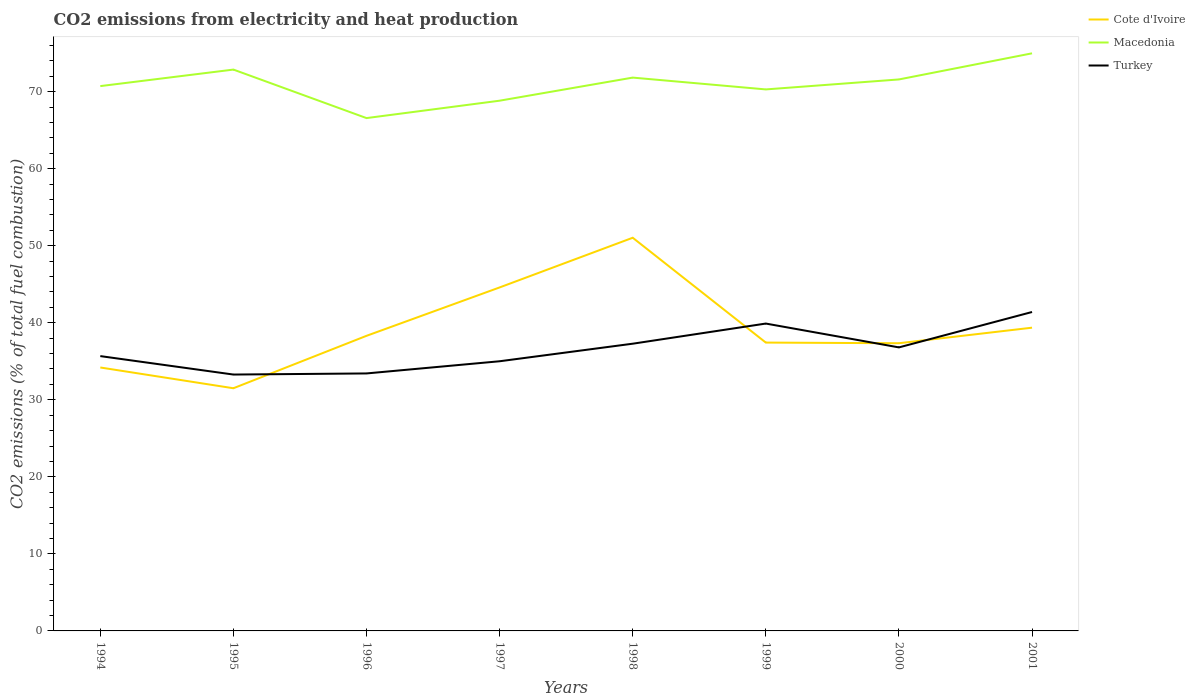How many different coloured lines are there?
Offer a terse response. 3. Does the line corresponding to Cote d'Ivoire intersect with the line corresponding to Turkey?
Give a very brief answer. Yes. Across all years, what is the maximum amount of CO2 emitted in Turkey?
Provide a short and direct response. 33.28. What is the total amount of CO2 emitted in Turkey in the graph?
Offer a terse response. -6.39. What is the difference between the highest and the second highest amount of CO2 emitted in Macedonia?
Provide a short and direct response. 8.41. How many years are there in the graph?
Your answer should be compact. 8. What is the difference between two consecutive major ticks on the Y-axis?
Ensure brevity in your answer.  10. Are the values on the major ticks of Y-axis written in scientific E-notation?
Your answer should be very brief. No. Does the graph contain any zero values?
Make the answer very short. No. Does the graph contain grids?
Provide a succinct answer. No. Where does the legend appear in the graph?
Your response must be concise. Top right. How are the legend labels stacked?
Your answer should be compact. Vertical. What is the title of the graph?
Provide a succinct answer. CO2 emissions from electricity and heat production. Does "Palau" appear as one of the legend labels in the graph?
Your response must be concise. No. What is the label or title of the Y-axis?
Keep it short and to the point. CO2 emissions (% of total fuel combustion). What is the CO2 emissions (% of total fuel combustion) of Cote d'Ivoire in 1994?
Your response must be concise. 34.19. What is the CO2 emissions (% of total fuel combustion) of Macedonia in 1994?
Ensure brevity in your answer.  70.72. What is the CO2 emissions (% of total fuel combustion) of Turkey in 1994?
Keep it short and to the point. 35.67. What is the CO2 emissions (% of total fuel combustion) of Cote d'Ivoire in 1995?
Provide a short and direct response. 31.5. What is the CO2 emissions (% of total fuel combustion) of Macedonia in 1995?
Give a very brief answer. 72.86. What is the CO2 emissions (% of total fuel combustion) of Turkey in 1995?
Offer a terse response. 33.28. What is the CO2 emissions (% of total fuel combustion) of Cote d'Ivoire in 1996?
Offer a very short reply. 38.3. What is the CO2 emissions (% of total fuel combustion) of Macedonia in 1996?
Your response must be concise. 66.56. What is the CO2 emissions (% of total fuel combustion) in Turkey in 1996?
Your answer should be compact. 33.42. What is the CO2 emissions (% of total fuel combustion) in Cote d'Ivoire in 1997?
Provide a succinct answer. 44.58. What is the CO2 emissions (% of total fuel combustion) in Macedonia in 1997?
Ensure brevity in your answer.  68.82. What is the CO2 emissions (% of total fuel combustion) in Turkey in 1997?
Your answer should be compact. 35. What is the CO2 emissions (% of total fuel combustion) of Cote d'Ivoire in 1998?
Provide a succinct answer. 51.03. What is the CO2 emissions (% of total fuel combustion) of Macedonia in 1998?
Offer a terse response. 71.82. What is the CO2 emissions (% of total fuel combustion) in Turkey in 1998?
Your answer should be compact. 37.28. What is the CO2 emissions (% of total fuel combustion) in Cote d'Ivoire in 1999?
Make the answer very short. 37.43. What is the CO2 emissions (% of total fuel combustion) in Macedonia in 1999?
Your answer should be very brief. 70.29. What is the CO2 emissions (% of total fuel combustion) of Turkey in 1999?
Offer a terse response. 39.89. What is the CO2 emissions (% of total fuel combustion) in Cote d'Ivoire in 2000?
Offer a terse response. 37.34. What is the CO2 emissions (% of total fuel combustion) in Macedonia in 2000?
Your answer should be compact. 71.58. What is the CO2 emissions (% of total fuel combustion) in Turkey in 2000?
Offer a terse response. 36.8. What is the CO2 emissions (% of total fuel combustion) of Cote d'Ivoire in 2001?
Provide a succinct answer. 39.36. What is the CO2 emissions (% of total fuel combustion) in Macedonia in 2001?
Provide a succinct answer. 74.97. What is the CO2 emissions (% of total fuel combustion) of Turkey in 2001?
Ensure brevity in your answer.  41.39. Across all years, what is the maximum CO2 emissions (% of total fuel combustion) in Cote d'Ivoire?
Your answer should be compact. 51.03. Across all years, what is the maximum CO2 emissions (% of total fuel combustion) in Macedonia?
Ensure brevity in your answer.  74.97. Across all years, what is the maximum CO2 emissions (% of total fuel combustion) of Turkey?
Ensure brevity in your answer.  41.39. Across all years, what is the minimum CO2 emissions (% of total fuel combustion) in Cote d'Ivoire?
Your answer should be very brief. 31.5. Across all years, what is the minimum CO2 emissions (% of total fuel combustion) of Macedonia?
Provide a succinct answer. 66.56. Across all years, what is the minimum CO2 emissions (% of total fuel combustion) in Turkey?
Offer a terse response. 33.28. What is the total CO2 emissions (% of total fuel combustion) of Cote d'Ivoire in the graph?
Offer a terse response. 313.74. What is the total CO2 emissions (% of total fuel combustion) in Macedonia in the graph?
Keep it short and to the point. 567.62. What is the total CO2 emissions (% of total fuel combustion) in Turkey in the graph?
Provide a succinct answer. 292.74. What is the difference between the CO2 emissions (% of total fuel combustion) in Cote d'Ivoire in 1994 and that in 1995?
Provide a short and direct response. 2.7. What is the difference between the CO2 emissions (% of total fuel combustion) of Macedonia in 1994 and that in 1995?
Give a very brief answer. -2.14. What is the difference between the CO2 emissions (% of total fuel combustion) of Turkey in 1994 and that in 1995?
Your answer should be very brief. 2.39. What is the difference between the CO2 emissions (% of total fuel combustion) of Cote d'Ivoire in 1994 and that in 1996?
Provide a short and direct response. -4.11. What is the difference between the CO2 emissions (% of total fuel combustion) of Macedonia in 1994 and that in 1996?
Your answer should be compact. 4.15. What is the difference between the CO2 emissions (% of total fuel combustion) of Turkey in 1994 and that in 1996?
Your answer should be very brief. 2.25. What is the difference between the CO2 emissions (% of total fuel combustion) of Cote d'Ivoire in 1994 and that in 1997?
Give a very brief answer. -10.39. What is the difference between the CO2 emissions (% of total fuel combustion) in Macedonia in 1994 and that in 1997?
Offer a terse response. 1.89. What is the difference between the CO2 emissions (% of total fuel combustion) of Turkey in 1994 and that in 1997?
Make the answer very short. 0.67. What is the difference between the CO2 emissions (% of total fuel combustion) of Cote d'Ivoire in 1994 and that in 1998?
Keep it short and to the point. -16.84. What is the difference between the CO2 emissions (% of total fuel combustion) of Macedonia in 1994 and that in 1998?
Your response must be concise. -1.1. What is the difference between the CO2 emissions (% of total fuel combustion) of Turkey in 1994 and that in 1998?
Your answer should be compact. -1.61. What is the difference between the CO2 emissions (% of total fuel combustion) in Cote d'Ivoire in 1994 and that in 1999?
Offer a terse response. -3.23. What is the difference between the CO2 emissions (% of total fuel combustion) of Macedonia in 1994 and that in 1999?
Your response must be concise. 0.43. What is the difference between the CO2 emissions (% of total fuel combustion) of Turkey in 1994 and that in 1999?
Make the answer very short. -4.22. What is the difference between the CO2 emissions (% of total fuel combustion) of Cote d'Ivoire in 1994 and that in 2000?
Make the answer very short. -3.15. What is the difference between the CO2 emissions (% of total fuel combustion) of Macedonia in 1994 and that in 2000?
Provide a short and direct response. -0.86. What is the difference between the CO2 emissions (% of total fuel combustion) in Turkey in 1994 and that in 2000?
Your answer should be very brief. -1.13. What is the difference between the CO2 emissions (% of total fuel combustion) in Cote d'Ivoire in 1994 and that in 2001?
Offer a very short reply. -5.17. What is the difference between the CO2 emissions (% of total fuel combustion) of Macedonia in 1994 and that in 2001?
Offer a very short reply. -4.25. What is the difference between the CO2 emissions (% of total fuel combustion) of Turkey in 1994 and that in 2001?
Offer a terse response. -5.72. What is the difference between the CO2 emissions (% of total fuel combustion) of Cote d'Ivoire in 1995 and that in 1996?
Your answer should be very brief. -6.8. What is the difference between the CO2 emissions (% of total fuel combustion) in Macedonia in 1995 and that in 1996?
Provide a short and direct response. 6.3. What is the difference between the CO2 emissions (% of total fuel combustion) in Turkey in 1995 and that in 1996?
Your answer should be compact. -0.14. What is the difference between the CO2 emissions (% of total fuel combustion) of Cote d'Ivoire in 1995 and that in 1997?
Keep it short and to the point. -13.08. What is the difference between the CO2 emissions (% of total fuel combustion) in Macedonia in 1995 and that in 1997?
Ensure brevity in your answer.  4.04. What is the difference between the CO2 emissions (% of total fuel combustion) in Turkey in 1995 and that in 1997?
Your answer should be compact. -1.72. What is the difference between the CO2 emissions (% of total fuel combustion) in Cote d'Ivoire in 1995 and that in 1998?
Provide a short and direct response. -19.53. What is the difference between the CO2 emissions (% of total fuel combustion) in Macedonia in 1995 and that in 1998?
Offer a very short reply. 1.04. What is the difference between the CO2 emissions (% of total fuel combustion) of Turkey in 1995 and that in 1998?
Your response must be concise. -4. What is the difference between the CO2 emissions (% of total fuel combustion) in Cote d'Ivoire in 1995 and that in 1999?
Ensure brevity in your answer.  -5.93. What is the difference between the CO2 emissions (% of total fuel combustion) in Macedonia in 1995 and that in 1999?
Make the answer very short. 2.57. What is the difference between the CO2 emissions (% of total fuel combustion) of Turkey in 1995 and that in 1999?
Make the answer very short. -6.62. What is the difference between the CO2 emissions (% of total fuel combustion) in Cote d'Ivoire in 1995 and that in 2000?
Your answer should be very brief. -5.84. What is the difference between the CO2 emissions (% of total fuel combustion) of Macedonia in 1995 and that in 2000?
Give a very brief answer. 1.28. What is the difference between the CO2 emissions (% of total fuel combustion) in Turkey in 1995 and that in 2000?
Keep it short and to the point. -3.53. What is the difference between the CO2 emissions (% of total fuel combustion) of Cote d'Ivoire in 1995 and that in 2001?
Offer a terse response. -7.86. What is the difference between the CO2 emissions (% of total fuel combustion) in Macedonia in 1995 and that in 2001?
Provide a succinct answer. -2.11. What is the difference between the CO2 emissions (% of total fuel combustion) in Turkey in 1995 and that in 2001?
Provide a short and direct response. -8.12. What is the difference between the CO2 emissions (% of total fuel combustion) of Cote d'Ivoire in 1996 and that in 1997?
Provide a short and direct response. -6.28. What is the difference between the CO2 emissions (% of total fuel combustion) of Macedonia in 1996 and that in 1997?
Your response must be concise. -2.26. What is the difference between the CO2 emissions (% of total fuel combustion) of Turkey in 1996 and that in 1997?
Your answer should be very brief. -1.58. What is the difference between the CO2 emissions (% of total fuel combustion) of Cote d'Ivoire in 1996 and that in 1998?
Offer a very short reply. -12.73. What is the difference between the CO2 emissions (% of total fuel combustion) in Macedonia in 1996 and that in 1998?
Offer a very short reply. -5.26. What is the difference between the CO2 emissions (% of total fuel combustion) of Turkey in 1996 and that in 1998?
Provide a succinct answer. -3.86. What is the difference between the CO2 emissions (% of total fuel combustion) in Cote d'Ivoire in 1996 and that in 1999?
Keep it short and to the point. 0.88. What is the difference between the CO2 emissions (% of total fuel combustion) in Macedonia in 1996 and that in 1999?
Offer a terse response. -3.72. What is the difference between the CO2 emissions (% of total fuel combustion) in Turkey in 1996 and that in 1999?
Your answer should be very brief. -6.47. What is the difference between the CO2 emissions (% of total fuel combustion) of Cote d'Ivoire in 1996 and that in 2000?
Ensure brevity in your answer.  0.96. What is the difference between the CO2 emissions (% of total fuel combustion) of Macedonia in 1996 and that in 2000?
Provide a succinct answer. -5.02. What is the difference between the CO2 emissions (% of total fuel combustion) of Turkey in 1996 and that in 2000?
Your answer should be compact. -3.38. What is the difference between the CO2 emissions (% of total fuel combustion) in Cote d'Ivoire in 1996 and that in 2001?
Give a very brief answer. -1.06. What is the difference between the CO2 emissions (% of total fuel combustion) of Macedonia in 1996 and that in 2001?
Your response must be concise. -8.41. What is the difference between the CO2 emissions (% of total fuel combustion) in Turkey in 1996 and that in 2001?
Provide a short and direct response. -7.97. What is the difference between the CO2 emissions (% of total fuel combustion) in Cote d'Ivoire in 1997 and that in 1998?
Your answer should be very brief. -6.45. What is the difference between the CO2 emissions (% of total fuel combustion) of Macedonia in 1997 and that in 1998?
Your answer should be very brief. -3. What is the difference between the CO2 emissions (% of total fuel combustion) of Turkey in 1997 and that in 1998?
Keep it short and to the point. -2.28. What is the difference between the CO2 emissions (% of total fuel combustion) of Cote d'Ivoire in 1997 and that in 1999?
Offer a terse response. 7.16. What is the difference between the CO2 emissions (% of total fuel combustion) in Macedonia in 1997 and that in 1999?
Keep it short and to the point. -1.46. What is the difference between the CO2 emissions (% of total fuel combustion) of Turkey in 1997 and that in 1999?
Your response must be concise. -4.89. What is the difference between the CO2 emissions (% of total fuel combustion) in Cote d'Ivoire in 1997 and that in 2000?
Keep it short and to the point. 7.24. What is the difference between the CO2 emissions (% of total fuel combustion) of Macedonia in 1997 and that in 2000?
Provide a short and direct response. -2.76. What is the difference between the CO2 emissions (% of total fuel combustion) of Turkey in 1997 and that in 2000?
Your response must be concise. -1.8. What is the difference between the CO2 emissions (% of total fuel combustion) in Cote d'Ivoire in 1997 and that in 2001?
Your answer should be very brief. 5.22. What is the difference between the CO2 emissions (% of total fuel combustion) in Macedonia in 1997 and that in 2001?
Ensure brevity in your answer.  -6.15. What is the difference between the CO2 emissions (% of total fuel combustion) in Turkey in 1997 and that in 2001?
Provide a short and direct response. -6.39. What is the difference between the CO2 emissions (% of total fuel combustion) in Cote d'Ivoire in 1998 and that in 1999?
Make the answer very short. 13.61. What is the difference between the CO2 emissions (% of total fuel combustion) in Macedonia in 1998 and that in 1999?
Ensure brevity in your answer.  1.53. What is the difference between the CO2 emissions (% of total fuel combustion) in Turkey in 1998 and that in 1999?
Provide a succinct answer. -2.61. What is the difference between the CO2 emissions (% of total fuel combustion) in Cote d'Ivoire in 1998 and that in 2000?
Offer a very short reply. 13.69. What is the difference between the CO2 emissions (% of total fuel combustion) in Macedonia in 1998 and that in 2000?
Your response must be concise. 0.24. What is the difference between the CO2 emissions (% of total fuel combustion) in Turkey in 1998 and that in 2000?
Keep it short and to the point. 0.48. What is the difference between the CO2 emissions (% of total fuel combustion) of Cote d'Ivoire in 1998 and that in 2001?
Offer a terse response. 11.67. What is the difference between the CO2 emissions (% of total fuel combustion) of Macedonia in 1998 and that in 2001?
Offer a terse response. -3.15. What is the difference between the CO2 emissions (% of total fuel combustion) in Turkey in 1998 and that in 2001?
Your answer should be compact. -4.11. What is the difference between the CO2 emissions (% of total fuel combustion) of Cote d'Ivoire in 1999 and that in 2000?
Give a very brief answer. 0.08. What is the difference between the CO2 emissions (% of total fuel combustion) of Macedonia in 1999 and that in 2000?
Your response must be concise. -1.3. What is the difference between the CO2 emissions (% of total fuel combustion) in Turkey in 1999 and that in 2000?
Your answer should be compact. 3.09. What is the difference between the CO2 emissions (% of total fuel combustion) of Cote d'Ivoire in 1999 and that in 2001?
Provide a succinct answer. -1.93. What is the difference between the CO2 emissions (% of total fuel combustion) of Macedonia in 1999 and that in 2001?
Offer a very short reply. -4.68. What is the difference between the CO2 emissions (% of total fuel combustion) in Cote d'Ivoire in 2000 and that in 2001?
Your response must be concise. -2.02. What is the difference between the CO2 emissions (% of total fuel combustion) in Macedonia in 2000 and that in 2001?
Make the answer very short. -3.39. What is the difference between the CO2 emissions (% of total fuel combustion) of Turkey in 2000 and that in 2001?
Keep it short and to the point. -4.59. What is the difference between the CO2 emissions (% of total fuel combustion) in Cote d'Ivoire in 1994 and the CO2 emissions (% of total fuel combustion) in Macedonia in 1995?
Keep it short and to the point. -38.67. What is the difference between the CO2 emissions (% of total fuel combustion) in Cote d'Ivoire in 1994 and the CO2 emissions (% of total fuel combustion) in Turkey in 1995?
Provide a short and direct response. 0.92. What is the difference between the CO2 emissions (% of total fuel combustion) in Macedonia in 1994 and the CO2 emissions (% of total fuel combustion) in Turkey in 1995?
Your answer should be compact. 37.44. What is the difference between the CO2 emissions (% of total fuel combustion) of Cote d'Ivoire in 1994 and the CO2 emissions (% of total fuel combustion) of Macedonia in 1996?
Keep it short and to the point. -32.37. What is the difference between the CO2 emissions (% of total fuel combustion) in Cote d'Ivoire in 1994 and the CO2 emissions (% of total fuel combustion) in Turkey in 1996?
Your answer should be very brief. 0.77. What is the difference between the CO2 emissions (% of total fuel combustion) in Macedonia in 1994 and the CO2 emissions (% of total fuel combustion) in Turkey in 1996?
Offer a terse response. 37.3. What is the difference between the CO2 emissions (% of total fuel combustion) in Cote d'Ivoire in 1994 and the CO2 emissions (% of total fuel combustion) in Macedonia in 1997?
Your response must be concise. -34.63. What is the difference between the CO2 emissions (% of total fuel combustion) of Cote d'Ivoire in 1994 and the CO2 emissions (% of total fuel combustion) of Turkey in 1997?
Offer a terse response. -0.81. What is the difference between the CO2 emissions (% of total fuel combustion) in Macedonia in 1994 and the CO2 emissions (% of total fuel combustion) in Turkey in 1997?
Keep it short and to the point. 35.72. What is the difference between the CO2 emissions (% of total fuel combustion) of Cote d'Ivoire in 1994 and the CO2 emissions (% of total fuel combustion) of Macedonia in 1998?
Provide a succinct answer. -37.63. What is the difference between the CO2 emissions (% of total fuel combustion) of Cote d'Ivoire in 1994 and the CO2 emissions (% of total fuel combustion) of Turkey in 1998?
Offer a terse response. -3.09. What is the difference between the CO2 emissions (% of total fuel combustion) in Macedonia in 1994 and the CO2 emissions (% of total fuel combustion) in Turkey in 1998?
Provide a short and direct response. 33.44. What is the difference between the CO2 emissions (% of total fuel combustion) in Cote d'Ivoire in 1994 and the CO2 emissions (% of total fuel combustion) in Macedonia in 1999?
Make the answer very short. -36.09. What is the difference between the CO2 emissions (% of total fuel combustion) in Cote d'Ivoire in 1994 and the CO2 emissions (% of total fuel combustion) in Turkey in 1999?
Your answer should be very brief. -5.7. What is the difference between the CO2 emissions (% of total fuel combustion) of Macedonia in 1994 and the CO2 emissions (% of total fuel combustion) of Turkey in 1999?
Offer a very short reply. 30.82. What is the difference between the CO2 emissions (% of total fuel combustion) in Cote d'Ivoire in 1994 and the CO2 emissions (% of total fuel combustion) in Macedonia in 2000?
Offer a very short reply. -37.39. What is the difference between the CO2 emissions (% of total fuel combustion) in Cote d'Ivoire in 1994 and the CO2 emissions (% of total fuel combustion) in Turkey in 2000?
Make the answer very short. -2.61. What is the difference between the CO2 emissions (% of total fuel combustion) in Macedonia in 1994 and the CO2 emissions (% of total fuel combustion) in Turkey in 2000?
Provide a succinct answer. 33.91. What is the difference between the CO2 emissions (% of total fuel combustion) in Cote d'Ivoire in 1994 and the CO2 emissions (% of total fuel combustion) in Macedonia in 2001?
Provide a short and direct response. -40.78. What is the difference between the CO2 emissions (% of total fuel combustion) in Cote d'Ivoire in 1994 and the CO2 emissions (% of total fuel combustion) in Turkey in 2001?
Make the answer very short. -7.2. What is the difference between the CO2 emissions (% of total fuel combustion) in Macedonia in 1994 and the CO2 emissions (% of total fuel combustion) in Turkey in 2001?
Ensure brevity in your answer.  29.32. What is the difference between the CO2 emissions (% of total fuel combustion) in Cote d'Ivoire in 1995 and the CO2 emissions (% of total fuel combustion) in Macedonia in 1996?
Make the answer very short. -35.07. What is the difference between the CO2 emissions (% of total fuel combustion) in Cote d'Ivoire in 1995 and the CO2 emissions (% of total fuel combustion) in Turkey in 1996?
Ensure brevity in your answer.  -1.92. What is the difference between the CO2 emissions (% of total fuel combustion) in Macedonia in 1995 and the CO2 emissions (% of total fuel combustion) in Turkey in 1996?
Offer a very short reply. 39.44. What is the difference between the CO2 emissions (% of total fuel combustion) in Cote d'Ivoire in 1995 and the CO2 emissions (% of total fuel combustion) in Macedonia in 1997?
Keep it short and to the point. -37.32. What is the difference between the CO2 emissions (% of total fuel combustion) of Cote d'Ivoire in 1995 and the CO2 emissions (% of total fuel combustion) of Turkey in 1997?
Offer a terse response. -3.5. What is the difference between the CO2 emissions (% of total fuel combustion) in Macedonia in 1995 and the CO2 emissions (% of total fuel combustion) in Turkey in 1997?
Ensure brevity in your answer.  37.86. What is the difference between the CO2 emissions (% of total fuel combustion) of Cote d'Ivoire in 1995 and the CO2 emissions (% of total fuel combustion) of Macedonia in 1998?
Make the answer very short. -40.32. What is the difference between the CO2 emissions (% of total fuel combustion) in Cote d'Ivoire in 1995 and the CO2 emissions (% of total fuel combustion) in Turkey in 1998?
Keep it short and to the point. -5.78. What is the difference between the CO2 emissions (% of total fuel combustion) of Macedonia in 1995 and the CO2 emissions (% of total fuel combustion) of Turkey in 1998?
Your answer should be compact. 35.58. What is the difference between the CO2 emissions (% of total fuel combustion) of Cote d'Ivoire in 1995 and the CO2 emissions (% of total fuel combustion) of Macedonia in 1999?
Your answer should be compact. -38.79. What is the difference between the CO2 emissions (% of total fuel combustion) in Cote d'Ivoire in 1995 and the CO2 emissions (% of total fuel combustion) in Turkey in 1999?
Your answer should be compact. -8.4. What is the difference between the CO2 emissions (% of total fuel combustion) of Macedonia in 1995 and the CO2 emissions (% of total fuel combustion) of Turkey in 1999?
Provide a succinct answer. 32.97. What is the difference between the CO2 emissions (% of total fuel combustion) in Cote d'Ivoire in 1995 and the CO2 emissions (% of total fuel combustion) in Macedonia in 2000?
Your answer should be compact. -40.08. What is the difference between the CO2 emissions (% of total fuel combustion) in Cote d'Ivoire in 1995 and the CO2 emissions (% of total fuel combustion) in Turkey in 2000?
Make the answer very short. -5.3. What is the difference between the CO2 emissions (% of total fuel combustion) in Macedonia in 1995 and the CO2 emissions (% of total fuel combustion) in Turkey in 2000?
Your response must be concise. 36.06. What is the difference between the CO2 emissions (% of total fuel combustion) of Cote d'Ivoire in 1995 and the CO2 emissions (% of total fuel combustion) of Macedonia in 2001?
Provide a short and direct response. -43.47. What is the difference between the CO2 emissions (% of total fuel combustion) of Cote d'Ivoire in 1995 and the CO2 emissions (% of total fuel combustion) of Turkey in 2001?
Ensure brevity in your answer.  -9.9. What is the difference between the CO2 emissions (% of total fuel combustion) of Macedonia in 1995 and the CO2 emissions (% of total fuel combustion) of Turkey in 2001?
Give a very brief answer. 31.47. What is the difference between the CO2 emissions (% of total fuel combustion) of Cote d'Ivoire in 1996 and the CO2 emissions (% of total fuel combustion) of Macedonia in 1997?
Your answer should be compact. -30.52. What is the difference between the CO2 emissions (% of total fuel combustion) of Cote d'Ivoire in 1996 and the CO2 emissions (% of total fuel combustion) of Turkey in 1997?
Make the answer very short. 3.3. What is the difference between the CO2 emissions (% of total fuel combustion) in Macedonia in 1996 and the CO2 emissions (% of total fuel combustion) in Turkey in 1997?
Your response must be concise. 31.56. What is the difference between the CO2 emissions (% of total fuel combustion) of Cote d'Ivoire in 1996 and the CO2 emissions (% of total fuel combustion) of Macedonia in 1998?
Your answer should be compact. -33.52. What is the difference between the CO2 emissions (% of total fuel combustion) in Cote d'Ivoire in 1996 and the CO2 emissions (% of total fuel combustion) in Turkey in 1998?
Ensure brevity in your answer.  1.02. What is the difference between the CO2 emissions (% of total fuel combustion) of Macedonia in 1996 and the CO2 emissions (% of total fuel combustion) of Turkey in 1998?
Make the answer very short. 29.28. What is the difference between the CO2 emissions (% of total fuel combustion) of Cote d'Ivoire in 1996 and the CO2 emissions (% of total fuel combustion) of Macedonia in 1999?
Offer a very short reply. -31.98. What is the difference between the CO2 emissions (% of total fuel combustion) in Cote d'Ivoire in 1996 and the CO2 emissions (% of total fuel combustion) in Turkey in 1999?
Ensure brevity in your answer.  -1.59. What is the difference between the CO2 emissions (% of total fuel combustion) of Macedonia in 1996 and the CO2 emissions (% of total fuel combustion) of Turkey in 1999?
Your answer should be very brief. 26.67. What is the difference between the CO2 emissions (% of total fuel combustion) of Cote d'Ivoire in 1996 and the CO2 emissions (% of total fuel combustion) of Macedonia in 2000?
Make the answer very short. -33.28. What is the difference between the CO2 emissions (% of total fuel combustion) in Cote d'Ivoire in 1996 and the CO2 emissions (% of total fuel combustion) in Turkey in 2000?
Keep it short and to the point. 1.5. What is the difference between the CO2 emissions (% of total fuel combustion) of Macedonia in 1996 and the CO2 emissions (% of total fuel combustion) of Turkey in 2000?
Provide a short and direct response. 29.76. What is the difference between the CO2 emissions (% of total fuel combustion) in Cote d'Ivoire in 1996 and the CO2 emissions (% of total fuel combustion) in Macedonia in 2001?
Your answer should be very brief. -36.67. What is the difference between the CO2 emissions (% of total fuel combustion) of Cote d'Ivoire in 1996 and the CO2 emissions (% of total fuel combustion) of Turkey in 2001?
Provide a succinct answer. -3.09. What is the difference between the CO2 emissions (% of total fuel combustion) of Macedonia in 1996 and the CO2 emissions (% of total fuel combustion) of Turkey in 2001?
Provide a short and direct response. 25.17. What is the difference between the CO2 emissions (% of total fuel combustion) in Cote d'Ivoire in 1997 and the CO2 emissions (% of total fuel combustion) in Macedonia in 1998?
Ensure brevity in your answer.  -27.24. What is the difference between the CO2 emissions (% of total fuel combustion) in Cote d'Ivoire in 1997 and the CO2 emissions (% of total fuel combustion) in Turkey in 1998?
Make the answer very short. 7.3. What is the difference between the CO2 emissions (% of total fuel combustion) of Macedonia in 1997 and the CO2 emissions (% of total fuel combustion) of Turkey in 1998?
Give a very brief answer. 31.54. What is the difference between the CO2 emissions (% of total fuel combustion) in Cote d'Ivoire in 1997 and the CO2 emissions (% of total fuel combustion) in Macedonia in 1999?
Your answer should be compact. -25.7. What is the difference between the CO2 emissions (% of total fuel combustion) of Cote d'Ivoire in 1997 and the CO2 emissions (% of total fuel combustion) of Turkey in 1999?
Your answer should be very brief. 4.69. What is the difference between the CO2 emissions (% of total fuel combustion) in Macedonia in 1997 and the CO2 emissions (% of total fuel combustion) in Turkey in 1999?
Your response must be concise. 28.93. What is the difference between the CO2 emissions (% of total fuel combustion) in Cote d'Ivoire in 1997 and the CO2 emissions (% of total fuel combustion) in Macedonia in 2000?
Provide a succinct answer. -27. What is the difference between the CO2 emissions (% of total fuel combustion) in Cote d'Ivoire in 1997 and the CO2 emissions (% of total fuel combustion) in Turkey in 2000?
Your answer should be compact. 7.78. What is the difference between the CO2 emissions (% of total fuel combustion) in Macedonia in 1997 and the CO2 emissions (% of total fuel combustion) in Turkey in 2000?
Give a very brief answer. 32.02. What is the difference between the CO2 emissions (% of total fuel combustion) in Cote d'Ivoire in 1997 and the CO2 emissions (% of total fuel combustion) in Macedonia in 2001?
Keep it short and to the point. -30.39. What is the difference between the CO2 emissions (% of total fuel combustion) of Cote d'Ivoire in 1997 and the CO2 emissions (% of total fuel combustion) of Turkey in 2001?
Offer a very short reply. 3.19. What is the difference between the CO2 emissions (% of total fuel combustion) of Macedonia in 1997 and the CO2 emissions (% of total fuel combustion) of Turkey in 2001?
Your answer should be compact. 27.43. What is the difference between the CO2 emissions (% of total fuel combustion) of Cote d'Ivoire in 1998 and the CO2 emissions (% of total fuel combustion) of Macedonia in 1999?
Make the answer very short. -19.25. What is the difference between the CO2 emissions (% of total fuel combustion) in Cote d'Ivoire in 1998 and the CO2 emissions (% of total fuel combustion) in Turkey in 1999?
Offer a terse response. 11.14. What is the difference between the CO2 emissions (% of total fuel combustion) of Macedonia in 1998 and the CO2 emissions (% of total fuel combustion) of Turkey in 1999?
Provide a short and direct response. 31.92. What is the difference between the CO2 emissions (% of total fuel combustion) of Cote d'Ivoire in 1998 and the CO2 emissions (% of total fuel combustion) of Macedonia in 2000?
Ensure brevity in your answer.  -20.55. What is the difference between the CO2 emissions (% of total fuel combustion) in Cote d'Ivoire in 1998 and the CO2 emissions (% of total fuel combustion) in Turkey in 2000?
Provide a short and direct response. 14.23. What is the difference between the CO2 emissions (% of total fuel combustion) in Macedonia in 1998 and the CO2 emissions (% of total fuel combustion) in Turkey in 2000?
Ensure brevity in your answer.  35.02. What is the difference between the CO2 emissions (% of total fuel combustion) of Cote d'Ivoire in 1998 and the CO2 emissions (% of total fuel combustion) of Macedonia in 2001?
Your answer should be compact. -23.94. What is the difference between the CO2 emissions (% of total fuel combustion) of Cote d'Ivoire in 1998 and the CO2 emissions (% of total fuel combustion) of Turkey in 2001?
Provide a short and direct response. 9.64. What is the difference between the CO2 emissions (% of total fuel combustion) of Macedonia in 1998 and the CO2 emissions (% of total fuel combustion) of Turkey in 2001?
Your answer should be compact. 30.42. What is the difference between the CO2 emissions (% of total fuel combustion) in Cote d'Ivoire in 1999 and the CO2 emissions (% of total fuel combustion) in Macedonia in 2000?
Your response must be concise. -34.16. What is the difference between the CO2 emissions (% of total fuel combustion) of Cote d'Ivoire in 1999 and the CO2 emissions (% of total fuel combustion) of Turkey in 2000?
Your answer should be very brief. 0.62. What is the difference between the CO2 emissions (% of total fuel combustion) of Macedonia in 1999 and the CO2 emissions (% of total fuel combustion) of Turkey in 2000?
Give a very brief answer. 33.48. What is the difference between the CO2 emissions (% of total fuel combustion) in Cote d'Ivoire in 1999 and the CO2 emissions (% of total fuel combustion) in Macedonia in 2001?
Offer a very short reply. -37.55. What is the difference between the CO2 emissions (% of total fuel combustion) of Cote d'Ivoire in 1999 and the CO2 emissions (% of total fuel combustion) of Turkey in 2001?
Your answer should be very brief. -3.97. What is the difference between the CO2 emissions (% of total fuel combustion) of Macedonia in 1999 and the CO2 emissions (% of total fuel combustion) of Turkey in 2001?
Provide a short and direct response. 28.89. What is the difference between the CO2 emissions (% of total fuel combustion) of Cote d'Ivoire in 2000 and the CO2 emissions (% of total fuel combustion) of Macedonia in 2001?
Ensure brevity in your answer.  -37.63. What is the difference between the CO2 emissions (% of total fuel combustion) in Cote d'Ivoire in 2000 and the CO2 emissions (% of total fuel combustion) in Turkey in 2001?
Keep it short and to the point. -4.05. What is the difference between the CO2 emissions (% of total fuel combustion) of Macedonia in 2000 and the CO2 emissions (% of total fuel combustion) of Turkey in 2001?
Your answer should be compact. 30.19. What is the average CO2 emissions (% of total fuel combustion) in Cote d'Ivoire per year?
Make the answer very short. 39.22. What is the average CO2 emissions (% of total fuel combustion) in Macedonia per year?
Your answer should be very brief. 70.95. What is the average CO2 emissions (% of total fuel combustion) in Turkey per year?
Make the answer very short. 36.59. In the year 1994, what is the difference between the CO2 emissions (% of total fuel combustion) of Cote d'Ivoire and CO2 emissions (% of total fuel combustion) of Macedonia?
Keep it short and to the point. -36.52. In the year 1994, what is the difference between the CO2 emissions (% of total fuel combustion) in Cote d'Ivoire and CO2 emissions (% of total fuel combustion) in Turkey?
Your answer should be very brief. -1.48. In the year 1994, what is the difference between the CO2 emissions (% of total fuel combustion) in Macedonia and CO2 emissions (% of total fuel combustion) in Turkey?
Your answer should be compact. 35.05. In the year 1995, what is the difference between the CO2 emissions (% of total fuel combustion) in Cote d'Ivoire and CO2 emissions (% of total fuel combustion) in Macedonia?
Your response must be concise. -41.36. In the year 1995, what is the difference between the CO2 emissions (% of total fuel combustion) of Cote d'Ivoire and CO2 emissions (% of total fuel combustion) of Turkey?
Offer a terse response. -1.78. In the year 1995, what is the difference between the CO2 emissions (% of total fuel combustion) in Macedonia and CO2 emissions (% of total fuel combustion) in Turkey?
Give a very brief answer. 39.58. In the year 1996, what is the difference between the CO2 emissions (% of total fuel combustion) in Cote d'Ivoire and CO2 emissions (% of total fuel combustion) in Macedonia?
Your response must be concise. -28.26. In the year 1996, what is the difference between the CO2 emissions (% of total fuel combustion) of Cote d'Ivoire and CO2 emissions (% of total fuel combustion) of Turkey?
Your answer should be very brief. 4.88. In the year 1996, what is the difference between the CO2 emissions (% of total fuel combustion) in Macedonia and CO2 emissions (% of total fuel combustion) in Turkey?
Your response must be concise. 33.14. In the year 1997, what is the difference between the CO2 emissions (% of total fuel combustion) of Cote d'Ivoire and CO2 emissions (% of total fuel combustion) of Macedonia?
Provide a succinct answer. -24.24. In the year 1997, what is the difference between the CO2 emissions (% of total fuel combustion) of Cote d'Ivoire and CO2 emissions (% of total fuel combustion) of Turkey?
Ensure brevity in your answer.  9.58. In the year 1997, what is the difference between the CO2 emissions (% of total fuel combustion) in Macedonia and CO2 emissions (% of total fuel combustion) in Turkey?
Keep it short and to the point. 33.82. In the year 1998, what is the difference between the CO2 emissions (% of total fuel combustion) of Cote d'Ivoire and CO2 emissions (% of total fuel combustion) of Macedonia?
Ensure brevity in your answer.  -20.79. In the year 1998, what is the difference between the CO2 emissions (% of total fuel combustion) of Cote d'Ivoire and CO2 emissions (% of total fuel combustion) of Turkey?
Your response must be concise. 13.75. In the year 1998, what is the difference between the CO2 emissions (% of total fuel combustion) in Macedonia and CO2 emissions (% of total fuel combustion) in Turkey?
Provide a short and direct response. 34.54. In the year 1999, what is the difference between the CO2 emissions (% of total fuel combustion) of Cote d'Ivoire and CO2 emissions (% of total fuel combustion) of Macedonia?
Your answer should be very brief. -32.86. In the year 1999, what is the difference between the CO2 emissions (% of total fuel combustion) in Cote d'Ivoire and CO2 emissions (% of total fuel combustion) in Turkey?
Ensure brevity in your answer.  -2.47. In the year 1999, what is the difference between the CO2 emissions (% of total fuel combustion) in Macedonia and CO2 emissions (% of total fuel combustion) in Turkey?
Your answer should be compact. 30.39. In the year 2000, what is the difference between the CO2 emissions (% of total fuel combustion) in Cote d'Ivoire and CO2 emissions (% of total fuel combustion) in Macedonia?
Provide a short and direct response. -34.24. In the year 2000, what is the difference between the CO2 emissions (% of total fuel combustion) of Cote d'Ivoire and CO2 emissions (% of total fuel combustion) of Turkey?
Offer a terse response. 0.54. In the year 2000, what is the difference between the CO2 emissions (% of total fuel combustion) of Macedonia and CO2 emissions (% of total fuel combustion) of Turkey?
Offer a terse response. 34.78. In the year 2001, what is the difference between the CO2 emissions (% of total fuel combustion) in Cote d'Ivoire and CO2 emissions (% of total fuel combustion) in Macedonia?
Keep it short and to the point. -35.61. In the year 2001, what is the difference between the CO2 emissions (% of total fuel combustion) of Cote d'Ivoire and CO2 emissions (% of total fuel combustion) of Turkey?
Offer a terse response. -2.03. In the year 2001, what is the difference between the CO2 emissions (% of total fuel combustion) in Macedonia and CO2 emissions (% of total fuel combustion) in Turkey?
Offer a very short reply. 33.58. What is the ratio of the CO2 emissions (% of total fuel combustion) of Cote d'Ivoire in 1994 to that in 1995?
Provide a succinct answer. 1.09. What is the ratio of the CO2 emissions (% of total fuel combustion) in Macedonia in 1994 to that in 1995?
Offer a terse response. 0.97. What is the ratio of the CO2 emissions (% of total fuel combustion) in Turkey in 1994 to that in 1995?
Keep it short and to the point. 1.07. What is the ratio of the CO2 emissions (% of total fuel combustion) of Cote d'Ivoire in 1994 to that in 1996?
Keep it short and to the point. 0.89. What is the ratio of the CO2 emissions (% of total fuel combustion) in Macedonia in 1994 to that in 1996?
Offer a terse response. 1.06. What is the ratio of the CO2 emissions (% of total fuel combustion) of Turkey in 1994 to that in 1996?
Give a very brief answer. 1.07. What is the ratio of the CO2 emissions (% of total fuel combustion) in Cote d'Ivoire in 1994 to that in 1997?
Give a very brief answer. 0.77. What is the ratio of the CO2 emissions (% of total fuel combustion) of Macedonia in 1994 to that in 1997?
Give a very brief answer. 1.03. What is the ratio of the CO2 emissions (% of total fuel combustion) in Turkey in 1994 to that in 1997?
Your answer should be compact. 1.02. What is the ratio of the CO2 emissions (% of total fuel combustion) of Cote d'Ivoire in 1994 to that in 1998?
Make the answer very short. 0.67. What is the ratio of the CO2 emissions (% of total fuel combustion) in Macedonia in 1994 to that in 1998?
Give a very brief answer. 0.98. What is the ratio of the CO2 emissions (% of total fuel combustion) in Turkey in 1994 to that in 1998?
Make the answer very short. 0.96. What is the ratio of the CO2 emissions (% of total fuel combustion) in Cote d'Ivoire in 1994 to that in 1999?
Your response must be concise. 0.91. What is the ratio of the CO2 emissions (% of total fuel combustion) in Macedonia in 1994 to that in 1999?
Make the answer very short. 1.01. What is the ratio of the CO2 emissions (% of total fuel combustion) of Turkey in 1994 to that in 1999?
Your answer should be compact. 0.89. What is the ratio of the CO2 emissions (% of total fuel combustion) of Cote d'Ivoire in 1994 to that in 2000?
Make the answer very short. 0.92. What is the ratio of the CO2 emissions (% of total fuel combustion) of Macedonia in 1994 to that in 2000?
Provide a short and direct response. 0.99. What is the ratio of the CO2 emissions (% of total fuel combustion) of Turkey in 1994 to that in 2000?
Your response must be concise. 0.97. What is the ratio of the CO2 emissions (% of total fuel combustion) of Cote d'Ivoire in 1994 to that in 2001?
Your answer should be compact. 0.87. What is the ratio of the CO2 emissions (% of total fuel combustion) of Macedonia in 1994 to that in 2001?
Ensure brevity in your answer.  0.94. What is the ratio of the CO2 emissions (% of total fuel combustion) of Turkey in 1994 to that in 2001?
Offer a terse response. 0.86. What is the ratio of the CO2 emissions (% of total fuel combustion) of Cote d'Ivoire in 1995 to that in 1996?
Ensure brevity in your answer.  0.82. What is the ratio of the CO2 emissions (% of total fuel combustion) of Macedonia in 1995 to that in 1996?
Give a very brief answer. 1.09. What is the ratio of the CO2 emissions (% of total fuel combustion) of Cote d'Ivoire in 1995 to that in 1997?
Your answer should be very brief. 0.71. What is the ratio of the CO2 emissions (% of total fuel combustion) in Macedonia in 1995 to that in 1997?
Give a very brief answer. 1.06. What is the ratio of the CO2 emissions (% of total fuel combustion) in Turkey in 1995 to that in 1997?
Offer a terse response. 0.95. What is the ratio of the CO2 emissions (% of total fuel combustion) of Cote d'Ivoire in 1995 to that in 1998?
Provide a short and direct response. 0.62. What is the ratio of the CO2 emissions (% of total fuel combustion) in Macedonia in 1995 to that in 1998?
Provide a succinct answer. 1.01. What is the ratio of the CO2 emissions (% of total fuel combustion) in Turkey in 1995 to that in 1998?
Make the answer very short. 0.89. What is the ratio of the CO2 emissions (% of total fuel combustion) of Cote d'Ivoire in 1995 to that in 1999?
Your response must be concise. 0.84. What is the ratio of the CO2 emissions (% of total fuel combustion) of Macedonia in 1995 to that in 1999?
Provide a succinct answer. 1.04. What is the ratio of the CO2 emissions (% of total fuel combustion) in Turkey in 1995 to that in 1999?
Your answer should be compact. 0.83. What is the ratio of the CO2 emissions (% of total fuel combustion) in Cote d'Ivoire in 1995 to that in 2000?
Your answer should be very brief. 0.84. What is the ratio of the CO2 emissions (% of total fuel combustion) in Macedonia in 1995 to that in 2000?
Offer a very short reply. 1.02. What is the ratio of the CO2 emissions (% of total fuel combustion) of Turkey in 1995 to that in 2000?
Give a very brief answer. 0.9. What is the ratio of the CO2 emissions (% of total fuel combustion) of Cote d'Ivoire in 1995 to that in 2001?
Give a very brief answer. 0.8. What is the ratio of the CO2 emissions (% of total fuel combustion) of Macedonia in 1995 to that in 2001?
Make the answer very short. 0.97. What is the ratio of the CO2 emissions (% of total fuel combustion) of Turkey in 1995 to that in 2001?
Your response must be concise. 0.8. What is the ratio of the CO2 emissions (% of total fuel combustion) of Cote d'Ivoire in 1996 to that in 1997?
Provide a succinct answer. 0.86. What is the ratio of the CO2 emissions (% of total fuel combustion) in Macedonia in 1996 to that in 1997?
Your answer should be very brief. 0.97. What is the ratio of the CO2 emissions (% of total fuel combustion) in Turkey in 1996 to that in 1997?
Keep it short and to the point. 0.95. What is the ratio of the CO2 emissions (% of total fuel combustion) of Cote d'Ivoire in 1996 to that in 1998?
Provide a short and direct response. 0.75. What is the ratio of the CO2 emissions (% of total fuel combustion) in Macedonia in 1996 to that in 1998?
Provide a succinct answer. 0.93. What is the ratio of the CO2 emissions (% of total fuel combustion) in Turkey in 1996 to that in 1998?
Give a very brief answer. 0.9. What is the ratio of the CO2 emissions (% of total fuel combustion) of Cote d'Ivoire in 1996 to that in 1999?
Provide a short and direct response. 1.02. What is the ratio of the CO2 emissions (% of total fuel combustion) of Macedonia in 1996 to that in 1999?
Offer a very short reply. 0.95. What is the ratio of the CO2 emissions (% of total fuel combustion) in Turkey in 1996 to that in 1999?
Offer a terse response. 0.84. What is the ratio of the CO2 emissions (% of total fuel combustion) in Cote d'Ivoire in 1996 to that in 2000?
Provide a succinct answer. 1.03. What is the ratio of the CO2 emissions (% of total fuel combustion) in Macedonia in 1996 to that in 2000?
Your answer should be very brief. 0.93. What is the ratio of the CO2 emissions (% of total fuel combustion) in Turkey in 1996 to that in 2000?
Make the answer very short. 0.91. What is the ratio of the CO2 emissions (% of total fuel combustion) of Cote d'Ivoire in 1996 to that in 2001?
Give a very brief answer. 0.97. What is the ratio of the CO2 emissions (% of total fuel combustion) in Macedonia in 1996 to that in 2001?
Offer a very short reply. 0.89. What is the ratio of the CO2 emissions (% of total fuel combustion) of Turkey in 1996 to that in 2001?
Keep it short and to the point. 0.81. What is the ratio of the CO2 emissions (% of total fuel combustion) in Cote d'Ivoire in 1997 to that in 1998?
Provide a succinct answer. 0.87. What is the ratio of the CO2 emissions (% of total fuel combustion) of Macedonia in 1997 to that in 1998?
Offer a terse response. 0.96. What is the ratio of the CO2 emissions (% of total fuel combustion) in Turkey in 1997 to that in 1998?
Make the answer very short. 0.94. What is the ratio of the CO2 emissions (% of total fuel combustion) in Cote d'Ivoire in 1997 to that in 1999?
Your answer should be compact. 1.19. What is the ratio of the CO2 emissions (% of total fuel combustion) in Macedonia in 1997 to that in 1999?
Provide a succinct answer. 0.98. What is the ratio of the CO2 emissions (% of total fuel combustion) in Turkey in 1997 to that in 1999?
Your answer should be compact. 0.88. What is the ratio of the CO2 emissions (% of total fuel combustion) in Cote d'Ivoire in 1997 to that in 2000?
Your answer should be very brief. 1.19. What is the ratio of the CO2 emissions (% of total fuel combustion) in Macedonia in 1997 to that in 2000?
Your answer should be very brief. 0.96. What is the ratio of the CO2 emissions (% of total fuel combustion) of Turkey in 1997 to that in 2000?
Your answer should be compact. 0.95. What is the ratio of the CO2 emissions (% of total fuel combustion) of Cote d'Ivoire in 1997 to that in 2001?
Your response must be concise. 1.13. What is the ratio of the CO2 emissions (% of total fuel combustion) in Macedonia in 1997 to that in 2001?
Provide a succinct answer. 0.92. What is the ratio of the CO2 emissions (% of total fuel combustion) of Turkey in 1997 to that in 2001?
Your answer should be very brief. 0.85. What is the ratio of the CO2 emissions (% of total fuel combustion) of Cote d'Ivoire in 1998 to that in 1999?
Give a very brief answer. 1.36. What is the ratio of the CO2 emissions (% of total fuel combustion) in Macedonia in 1998 to that in 1999?
Your response must be concise. 1.02. What is the ratio of the CO2 emissions (% of total fuel combustion) in Turkey in 1998 to that in 1999?
Ensure brevity in your answer.  0.93. What is the ratio of the CO2 emissions (% of total fuel combustion) of Cote d'Ivoire in 1998 to that in 2000?
Ensure brevity in your answer.  1.37. What is the ratio of the CO2 emissions (% of total fuel combustion) in Cote d'Ivoire in 1998 to that in 2001?
Your answer should be compact. 1.3. What is the ratio of the CO2 emissions (% of total fuel combustion) of Macedonia in 1998 to that in 2001?
Provide a short and direct response. 0.96. What is the ratio of the CO2 emissions (% of total fuel combustion) in Turkey in 1998 to that in 2001?
Keep it short and to the point. 0.9. What is the ratio of the CO2 emissions (% of total fuel combustion) of Macedonia in 1999 to that in 2000?
Your answer should be very brief. 0.98. What is the ratio of the CO2 emissions (% of total fuel combustion) of Turkey in 1999 to that in 2000?
Make the answer very short. 1.08. What is the ratio of the CO2 emissions (% of total fuel combustion) in Cote d'Ivoire in 1999 to that in 2001?
Offer a terse response. 0.95. What is the ratio of the CO2 emissions (% of total fuel combustion) in Macedonia in 1999 to that in 2001?
Make the answer very short. 0.94. What is the ratio of the CO2 emissions (% of total fuel combustion) of Turkey in 1999 to that in 2001?
Offer a terse response. 0.96. What is the ratio of the CO2 emissions (% of total fuel combustion) of Cote d'Ivoire in 2000 to that in 2001?
Provide a succinct answer. 0.95. What is the ratio of the CO2 emissions (% of total fuel combustion) in Macedonia in 2000 to that in 2001?
Your answer should be very brief. 0.95. What is the ratio of the CO2 emissions (% of total fuel combustion) of Turkey in 2000 to that in 2001?
Your answer should be compact. 0.89. What is the difference between the highest and the second highest CO2 emissions (% of total fuel combustion) of Cote d'Ivoire?
Offer a very short reply. 6.45. What is the difference between the highest and the second highest CO2 emissions (% of total fuel combustion) in Macedonia?
Ensure brevity in your answer.  2.11. What is the difference between the highest and the lowest CO2 emissions (% of total fuel combustion) of Cote d'Ivoire?
Your response must be concise. 19.53. What is the difference between the highest and the lowest CO2 emissions (% of total fuel combustion) in Macedonia?
Offer a terse response. 8.41. What is the difference between the highest and the lowest CO2 emissions (% of total fuel combustion) in Turkey?
Give a very brief answer. 8.12. 